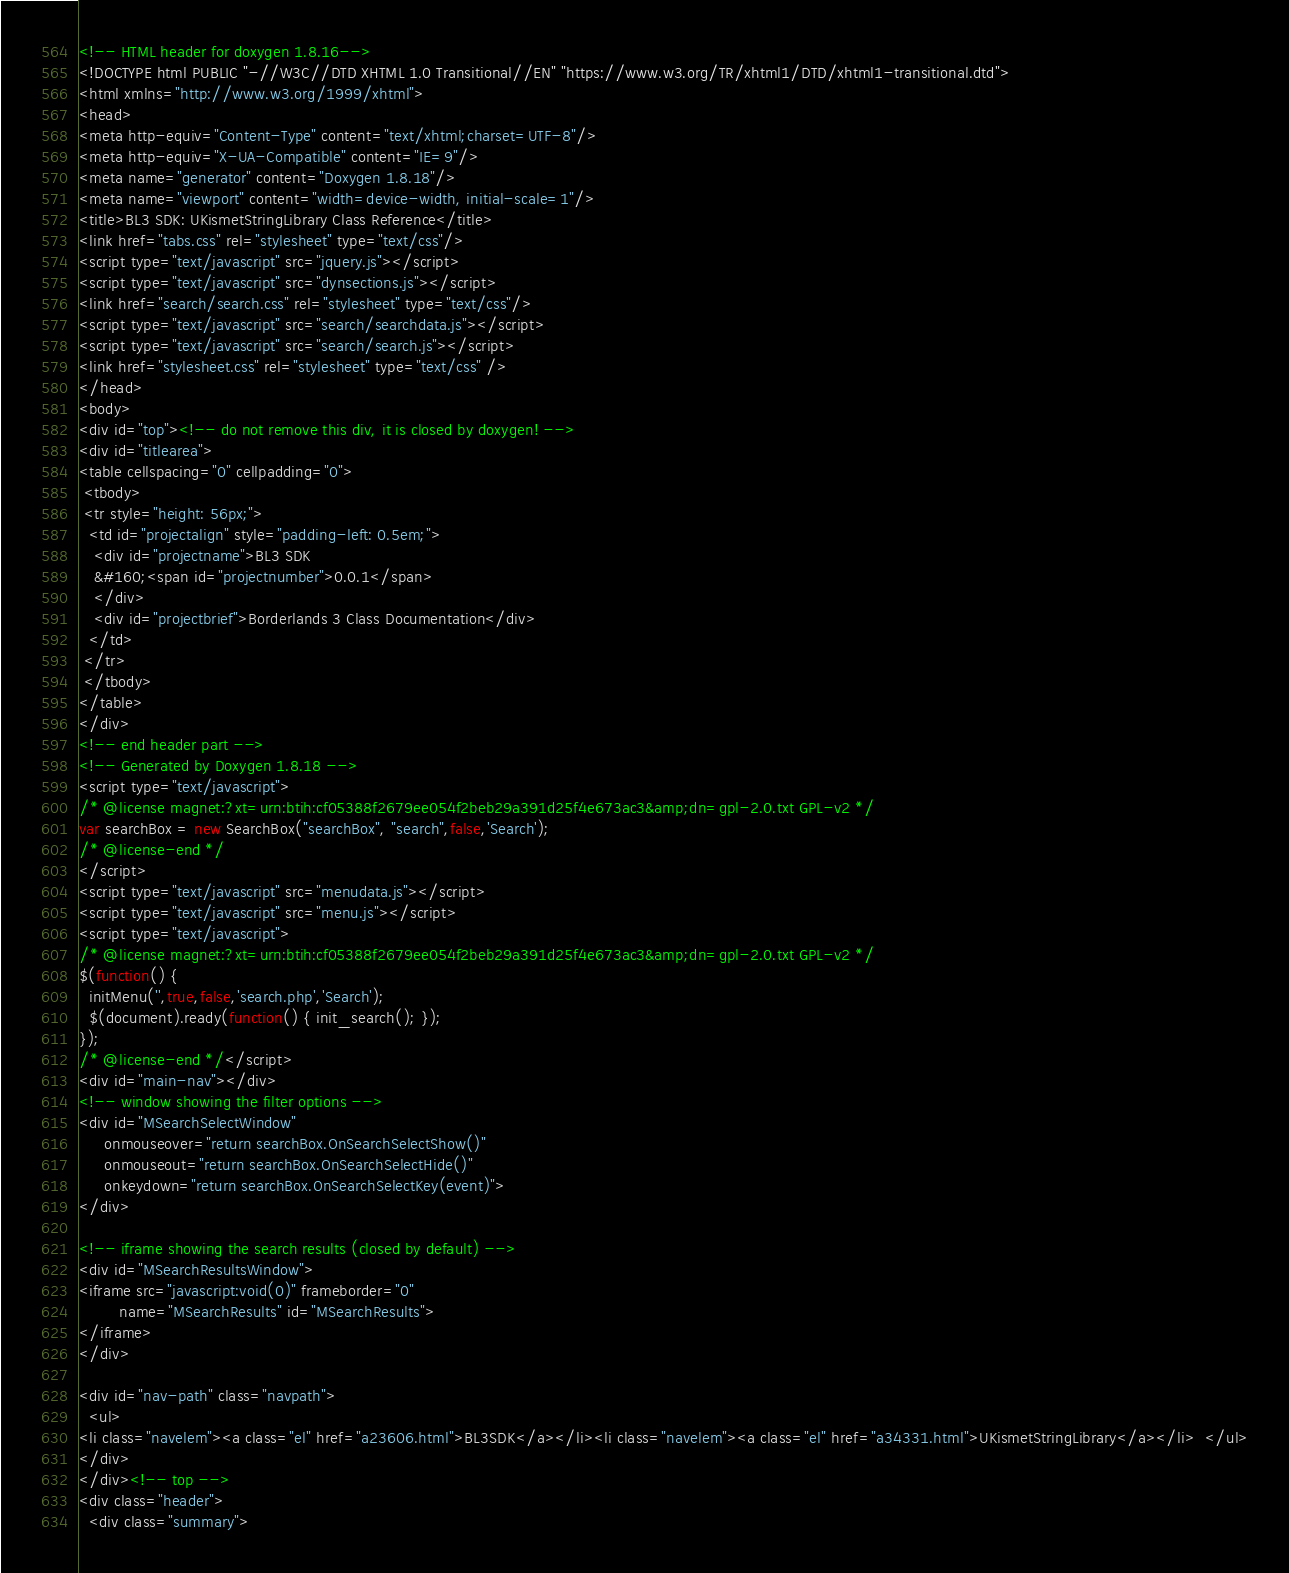Convert code to text. <code><loc_0><loc_0><loc_500><loc_500><_HTML_><!-- HTML header for doxygen 1.8.16-->
<!DOCTYPE html PUBLIC "-//W3C//DTD XHTML 1.0 Transitional//EN" "https://www.w3.org/TR/xhtml1/DTD/xhtml1-transitional.dtd">
<html xmlns="http://www.w3.org/1999/xhtml">
<head>
<meta http-equiv="Content-Type" content="text/xhtml;charset=UTF-8"/>
<meta http-equiv="X-UA-Compatible" content="IE=9"/>
<meta name="generator" content="Doxygen 1.8.18"/>
<meta name="viewport" content="width=device-width, initial-scale=1"/>
<title>BL3 SDK: UKismetStringLibrary Class Reference</title>
<link href="tabs.css" rel="stylesheet" type="text/css"/>
<script type="text/javascript" src="jquery.js"></script>
<script type="text/javascript" src="dynsections.js"></script>
<link href="search/search.css" rel="stylesheet" type="text/css"/>
<script type="text/javascript" src="search/searchdata.js"></script>
<script type="text/javascript" src="search/search.js"></script>
<link href="stylesheet.css" rel="stylesheet" type="text/css" />
</head>
<body>
<div id="top"><!-- do not remove this div, it is closed by doxygen! -->
<div id="titlearea">
<table cellspacing="0" cellpadding="0">
 <tbody>
 <tr style="height: 56px;">
  <td id="projectalign" style="padding-left: 0.5em;">
   <div id="projectname">BL3 SDK
   &#160;<span id="projectnumber">0.0.1</span>
   </div>
   <div id="projectbrief">Borderlands 3 Class Documentation</div>
  </td>
 </tr>
 </tbody>
</table>
</div>
<!-- end header part -->
<!-- Generated by Doxygen 1.8.18 -->
<script type="text/javascript">
/* @license magnet:?xt=urn:btih:cf05388f2679ee054f2beb29a391d25f4e673ac3&amp;dn=gpl-2.0.txt GPL-v2 */
var searchBox = new SearchBox("searchBox", "search",false,'Search');
/* @license-end */
</script>
<script type="text/javascript" src="menudata.js"></script>
<script type="text/javascript" src="menu.js"></script>
<script type="text/javascript">
/* @license magnet:?xt=urn:btih:cf05388f2679ee054f2beb29a391d25f4e673ac3&amp;dn=gpl-2.0.txt GPL-v2 */
$(function() {
  initMenu('',true,false,'search.php','Search');
  $(document).ready(function() { init_search(); });
});
/* @license-end */</script>
<div id="main-nav"></div>
<!-- window showing the filter options -->
<div id="MSearchSelectWindow"
     onmouseover="return searchBox.OnSearchSelectShow()"
     onmouseout="return searchBox.OnSearchSelectHide()"
     onkeydown="return searchBox.OnSearchSelectKey(event)">
</div>

<!-- iframe showing the search results (closed by default) -->
<div id="MSearchResultsWindow">
<iframe src="javascript:void(0)" frameborder="0" 
        name="MSearchResults" id="MSearchResults">
</iframe>
</div>

<div id="nav-path" class="navpath">
  <ul>
<li class="navelem"><a class="el" href="a23606.html">BL3SDK</a></li><li class="navelem"><a class="el" href="a34331.html">UKismetStringLibrary</a></li>  </ul>
</div>
</div><!-- top -->
<div class="header">
  <div class="summary"></code> 